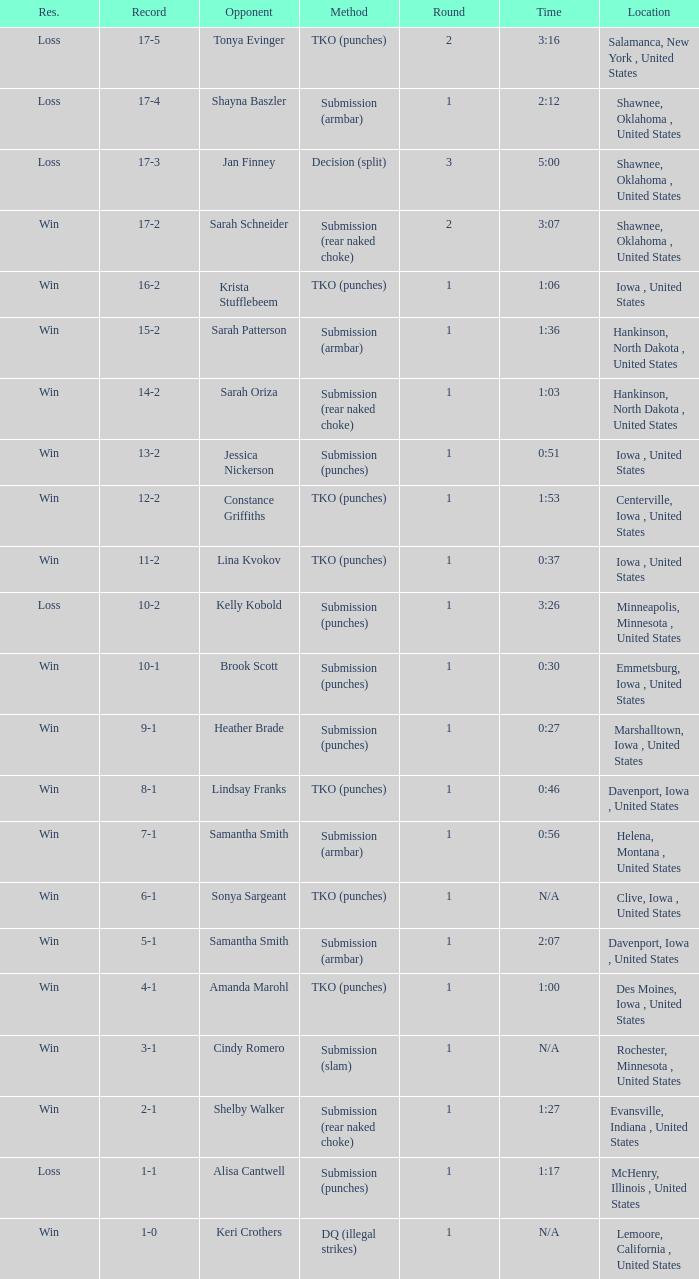Could you parse the entire table as a dict? {'header': ['Res.', 'Record', 'Opponent', 'Method', 'Round', 'Time', 'Location'], 'rows': [['Loss', '17-5', 'Tonya Evinger', 'TKO (punches)', '2', '3:16', 'Salamanca, New York , United States'], ['Loss', '17-4', 'Shayna Baszler', 'Submission (armbar)', '1', '2:12', 'Shawnee, Oklahoma , United States'], ['Loss', '17-3', 'Jan Finney', 'Decision (split)', '3', '5:00', 'Shawnee, Oklahoma , United States'], ['Win', '17-2', 'Sarah Schneider', 'Submission (rear naked choke)', '2', '3:07', 'Shawnee, Oklahoma , United States'], ['Win', '16-2', 'Krista Stufflebeem', 'TKO (punches)', '1', '1:06', 'Iowa , United States'], ['Win', '15-2', 'Sarah Patterson', 'Submission (armbar)', '1', '1:36', 'Hankinson, North Dakota , United States'], ['Win', '14-2', 'Sarah Oriza', 'Submission (rear naked choke)', '1', '1:03', 'Hankinson, North Dakota , United States'], ['Win', '13-2', 'Jessica Nickerson', 'Submission (punches)', '1', '0:51', 'Iowa , United States'], ['Win', '12-2', 'Constance Griffiths', 'TKO (punches)', '1', '1:53', 'Centerville, Iowa , United States'], ['Win', '11-2', 'Lina Kvokov', 'TKO (punches)', '1', '0:37', 'Iowa , United States'], ['Loss', '10-2', 'Kelly Kobold', 'Submission (punches)', '1', '3:26', 'Minneapolis, Minnesota , United States'], ['Win', '10-1', 'Brook Scott', 'Submission (punches)', '1', '0:30', 'Emmetsburg, Iowa , United States'], ['Win', '9-1', 'Heather Brade', 'Submission (punches)', '1', '0:27', 'Marshalltown, Iowa , United States'], ['Win', '8-1', 'Lindsay Franks', 'TKO (punches)', '1', '0:46', 'Davenport, Iowa , United States'], ['Win', '7-1', 'Samantha Smith', 'Submission (armbar)', '1', '0:56', 'Helena, Montana , United States'], ['Win', '6-1', 'Sonya Sargeant', 'TKO (punches)', '1', 'N/A', 'Clive, Iowa , United States'], ['Win', '5-1', 'Samantha Smith', 'Submission (armbar)', '1', '2:07', 'Davenport, Iowa , United States'], ['Win', '4-1', 'Amanda Marohl', 'TKO (punches)', '1', '1:00', 'Des Moines, Iowa , United States'], ['Win', '3-1', 'Cindy Romero', 'Submission (slam)', '1', 'N/A', 'Rochester, Minnesota , United States'], ['Win', '2-1', 'Shelby Walker', 'Submission (rear naked choke)', '1', '1:27', 'Evansville, Indiana , United States'], ['Loss', '1-1', 'Alisa Cantwell', 'Submission (punches)', '1', '1:17', 'McHenry, Illinois , United States'], ['Win', '1-0', 'Keri Crothers', 'DQ (illegal strikes)', '1', 'N/A', 'Lemoore, California , United States']]} What opponent does she fight when she is 10-1? Brook Scott. 